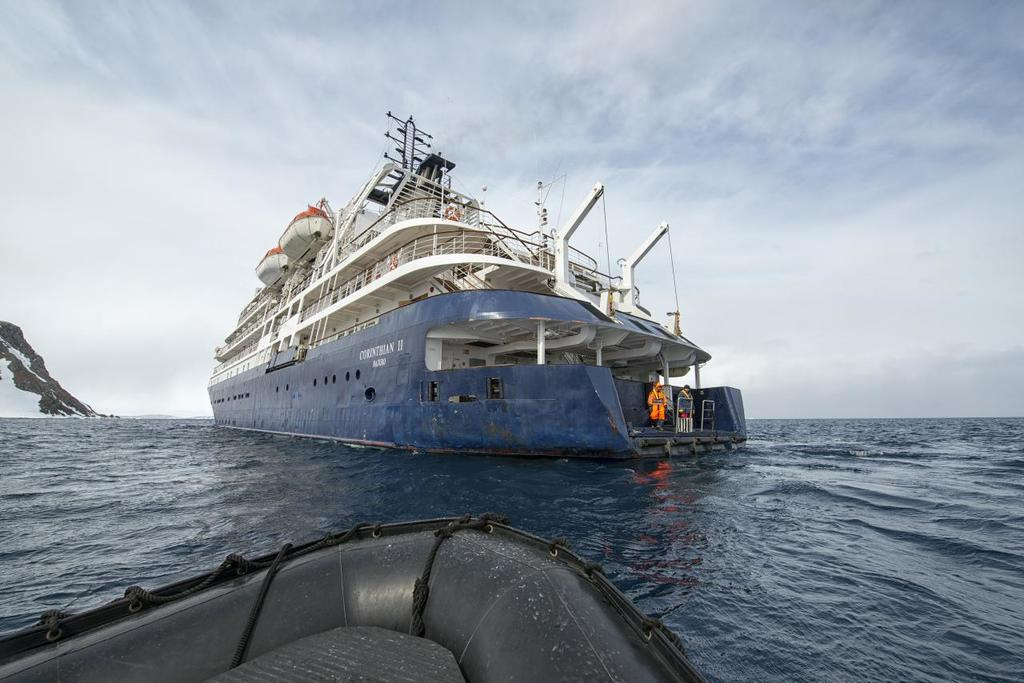What is the main subject of the image? The main subject of the image is a ship. What is the ship doing in the image? The ship is sailing on water in the image. What can be seen on the left side of the image? There is a mountain on the left side of the image. What is visible at the top of the image? The sky is visible at the top of the image. What is the condition of the sky in the image? The sky is clear in the image. What type of furniture can be seen on the ship in the image? There is no furniture visible on the ship in the image. How many geese are swimming alongside the ship in the image? There are no geese present in the image; the ship is sailing on water. 